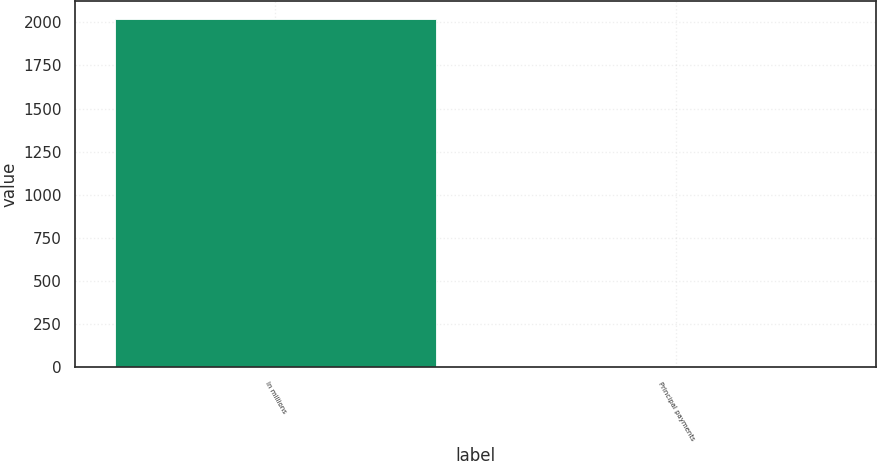<chart> <loc_0><loc_0><loc_500><loc_500><bar_chart><fcel>In millions<fcel>Principal payments<nl><fcel>2021<fcel>4<nl></chart> 